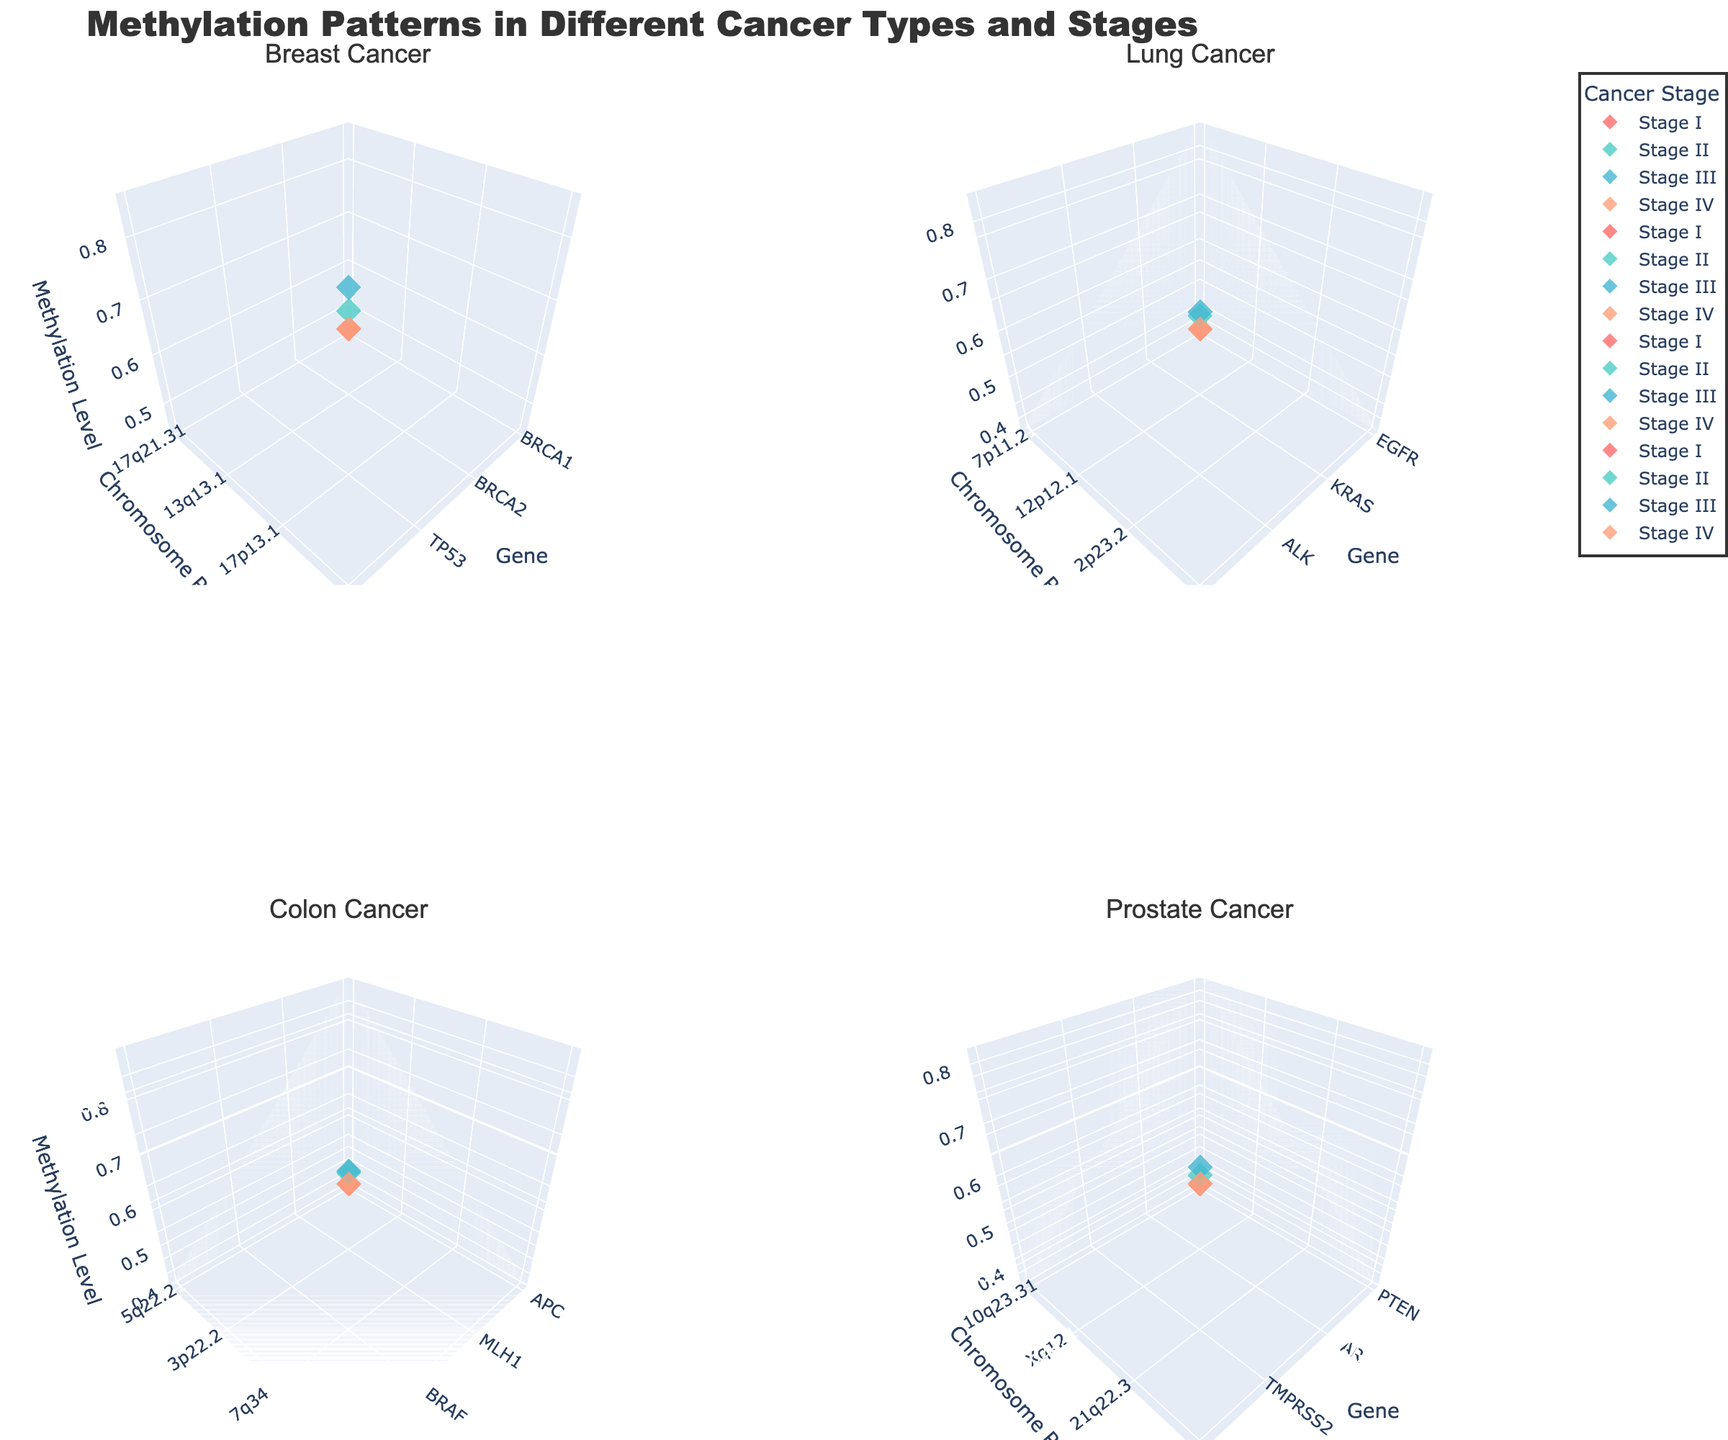What is the title of the figure? The title is displayed at the top center of the figure, which reads "Methylation Patterns in Different Cancer Types and Stages".
Answer: Methylation Patterns in Different Cancer Types and Stages How many subplots are present in the figure? There are four subplots, arranged in a 2x2 grid format, each representing different cancer types.
Answer: Four Which cancer stage has the highest methylation level in Prostate Cancer? In the subplot for Prostate Cancer, the Methylation Level axis shows that Stage IV has the highest methylation level with a value of 0.81.
Answer: Stage IV Which gene is represented in Stage I of Lung Cancer? In the Lung Cancer subplot, looking at Stage I, the gene plotted is EGFR.
Answer: EGFR Describe the marker color used for Stage II across all cancer types. Stage II markers are color-coded in a greenish-blue hue across all subplots.
Answer: Greenish-blue What is the average methylation level for genes in Breast Cancer Stage III and Stage IV? For Breast Cancer, the methylation levels in Stage III and Stage IV are 0.78 and 0.85 respectively. The average is (0.78 + 0.85) / 2 = 0.815.
Answer: 0.815 Compare the methylation levels of KRAS in Lung Cancer and Colon Cancer. Which one is higher? In the Lung Cancer subplot, KRAS (Stage II) has a methylation level of 0.56. In Colon Cancer, KRAS (Stage IV) has a methylation level of 0.87. KRAS in Colon Cancer is higher.
Answer: KRAS in Colon Cancer Identify the gene with the lowest methylation level in Breast Cancer and its stage. In the Breast Cancer subplot, the gene BRCA1 in Stage I has the lowest methylation level of 0.45.
Answer: BRCA1, Stage I Which cancer type has the gene with the highest overall methylation level? By examining the subplots, Colon Cancer Stage IV, with the gene KRAS, shows the highest overall methylation level of 0.87.
Answer: Colon Cancer 